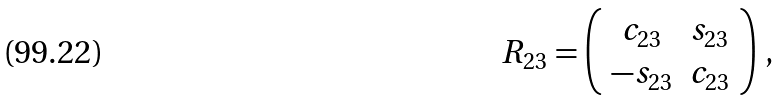Convert formula to latex. <formula><loc_0><loc_0><loc_500><loc_500>R _ { 2 3 } = \left ( \begin{array} { c c } c _ { 2 3 } & s _ { 2 3 } \\ - s _ { 2 3 } & c _ { 2 3 } \end{array} \right ) \, ,</formula> 